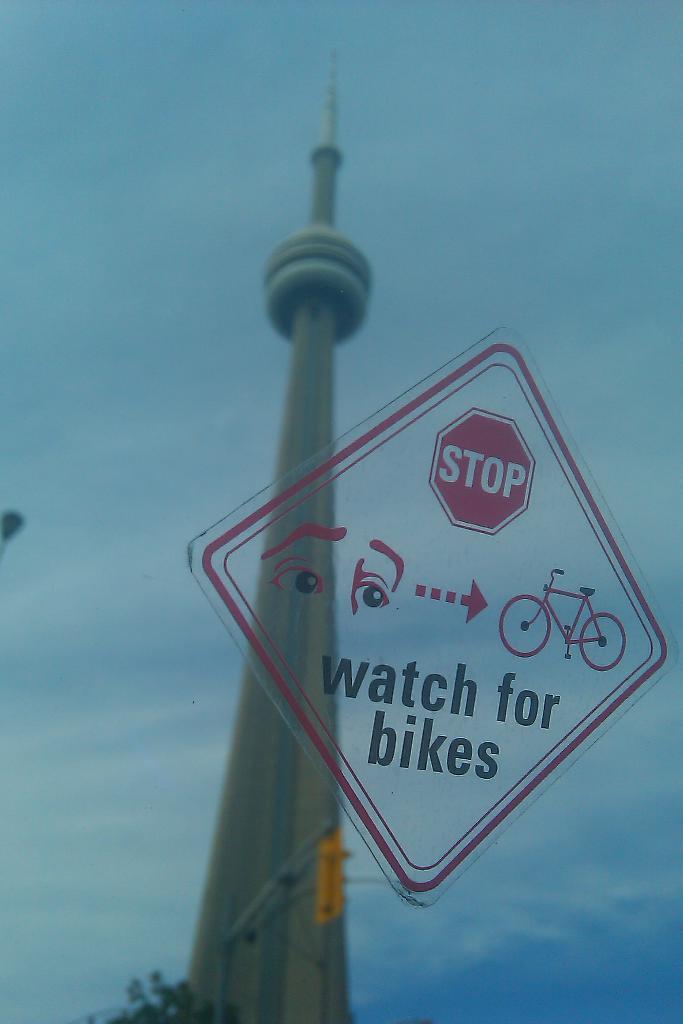What does the sign say?
Provide a short and direct response. Stop watch for bikes. 